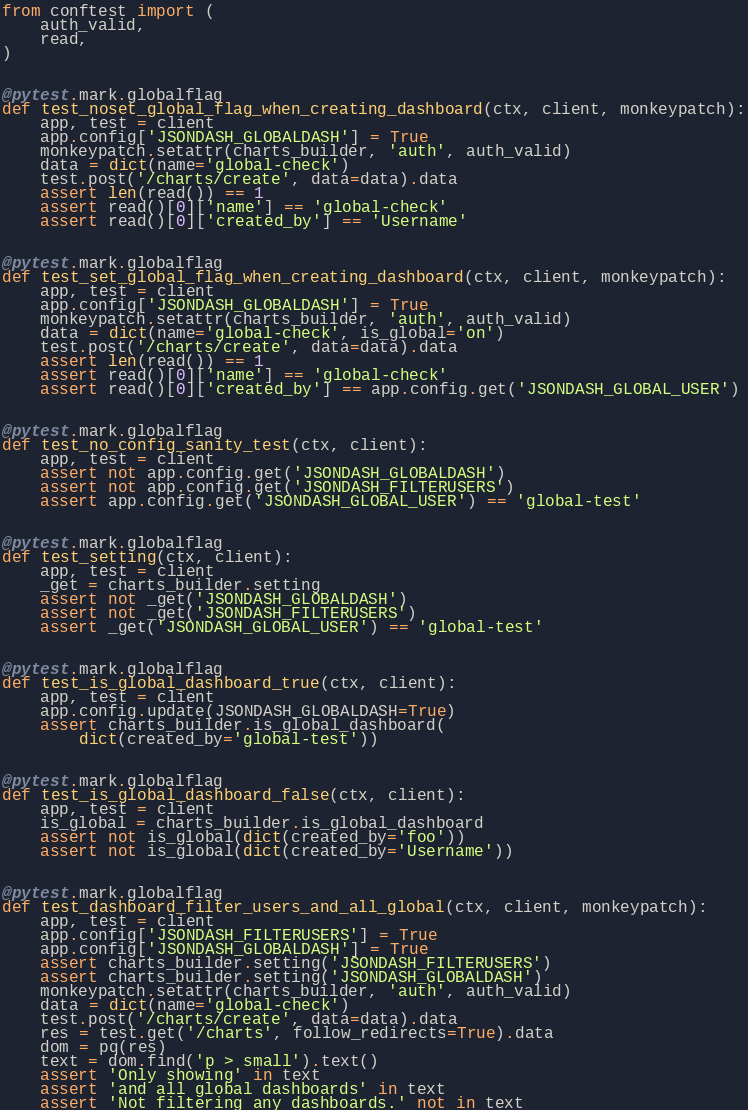<code> <loc_0><loc_0><loc_500><loc_500><_Python_>
from conftest import (
    auth_valid,
    read,
)


@pytest.mark.globalflag
def test_noset_global_flag_when_creating_dashboard(ctx, client, monkeypatch):
    app, test = client
    app.config['JSONDASH_GLOBALDASH'] = True
    monkeypatch.setattr(charts_builder, 'auth', auth_valid)
    data = dict(name='global-check')
    test.post('/charts/create', data=data).data
    assert len(read()) == 1
    assert read()[0]['name'] == 'global-check'
    assert read()[0]['created_by'] == 'Username'


@pytest.mark.globalflag
def test_set_global_flag_when_creating_dashboard(ctx, client, monkeypatch):
    app, test = client
    app.config['JSONDASH_GLOBALDASH'] = True
    monkeypatch.setattr(charts_builder, 'auth', auth_valid)
    data = dict(name='global-check', is_global='on')
    test.post('/charts/create', data=data).data
    assert len(read()) == 1
    assert read()[0]['name'] == 'global-check'
    assert read()[0]['created_by'] == app.config.get('JSONDASH_GLOBAL_USER')


@pytest.mark.globalflag
def test_no_config_sanity_test(ctx, client):
    app, test = client
    assert not app.config.get('JSONDASH_GLOBALDASH')
    assert not app.config.get('JSONDASH_FILTERUSERS')
    assert app.config.get('JSONDASH_GLOBAL_USER') == 'global-test'


@pytest.mark.globalflag
def test_setting(ctx, client):
    app, test = client
    _get = charts_builder.setting
    assert not _get('JSONDASH_GLOBALDASH')
    assert not _get('JSONDASH_FILTERUSERS')
    assert _get('JSONDASH_GLOBAL_USER') == 'global-test'


@pytest.mark.globalflag
def test_is_global_dashboard_true(ctx, client):
    app, test = client
    app.config.update(JSONDASH_GLOBALDASH=True)
    assert charts_builder.is_global_dashboard(
        dict(created_by='global-test'))


@pytest.mark.globalflag
def test_is_global_dashboard_false(ctx, client):
    app, test = client
    is_global = charts_builder.is_global_dashboard
    assert not is_global(dict(created_by='foo'))
    assert not is_global(dict(created_by='Username'))


@pytest.mark.globalflag
def test_dashboard_filter_users_and_all_global(ctx, client, monkeypatch):
    app, test = client
    app.config['JSONDASH_FILTERUSERS'] = True
    app.config['JSONDASH_GLOBALDASH'] = True
    assert charts_builder.setting('JSONDASH_FILTERUSERS')
    assert charts_builder.setting('JSONDASH_GLOBALDASH')
    monkeypatch.setattr(charts_builder, 'auth', auth_valid)
    data = dict(name='global-check')
    test.post('/charts/create', data=data).data
    res = test.get('/charts', follow_redirects=True).data
    dom = pq(res)
    text = dom.find('p > small').text()
    assert 'Only showing' in text
    assert 'and all global dashboards' in text
    assert 'Not filtering any dashboards.' not in text
</code> 